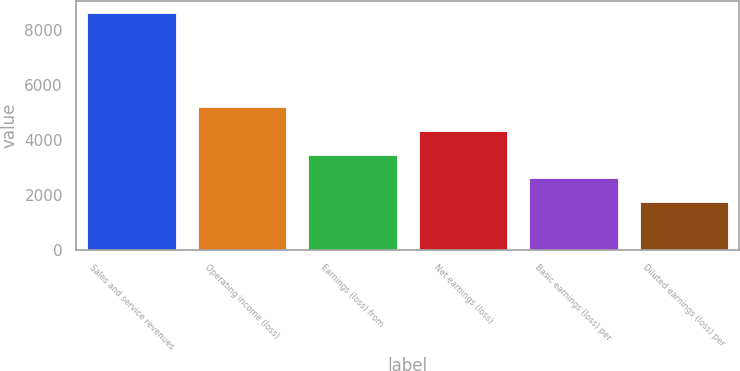<chart> <loc_0><loc_0><loc_500><loc_500><bar_chart><fcel>Sales and service revenues<fcel>Operating income (loss)<fcel>Earnings (loss) from<fcel>Net earnings (loss)<fcel>Basic earnings (loss) per<fcel>Diluted earnings (loss) per<nl><fcel>8628<fcel>5177.36<fcel>3452.04<fcel>4314.7<fcel>2589.38<fcel>1726.72<nl></chart> 